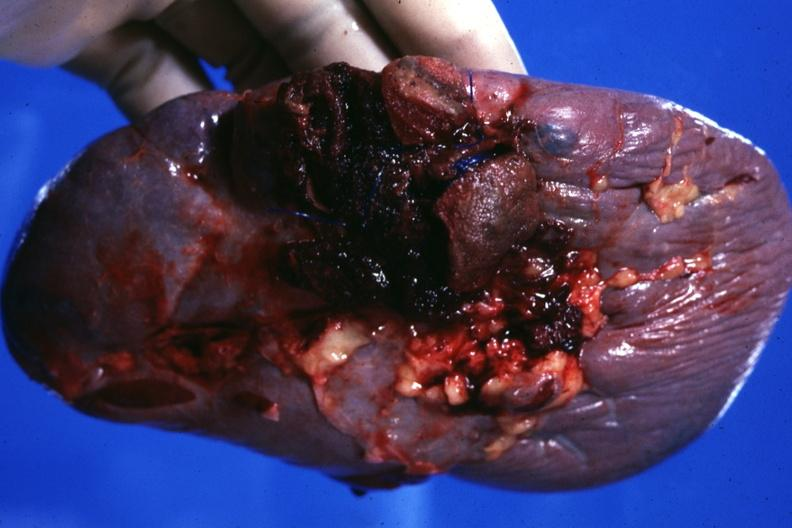does this image show close-up of ruptured area very good?
Answer the question using a single word or phrase. Yes 